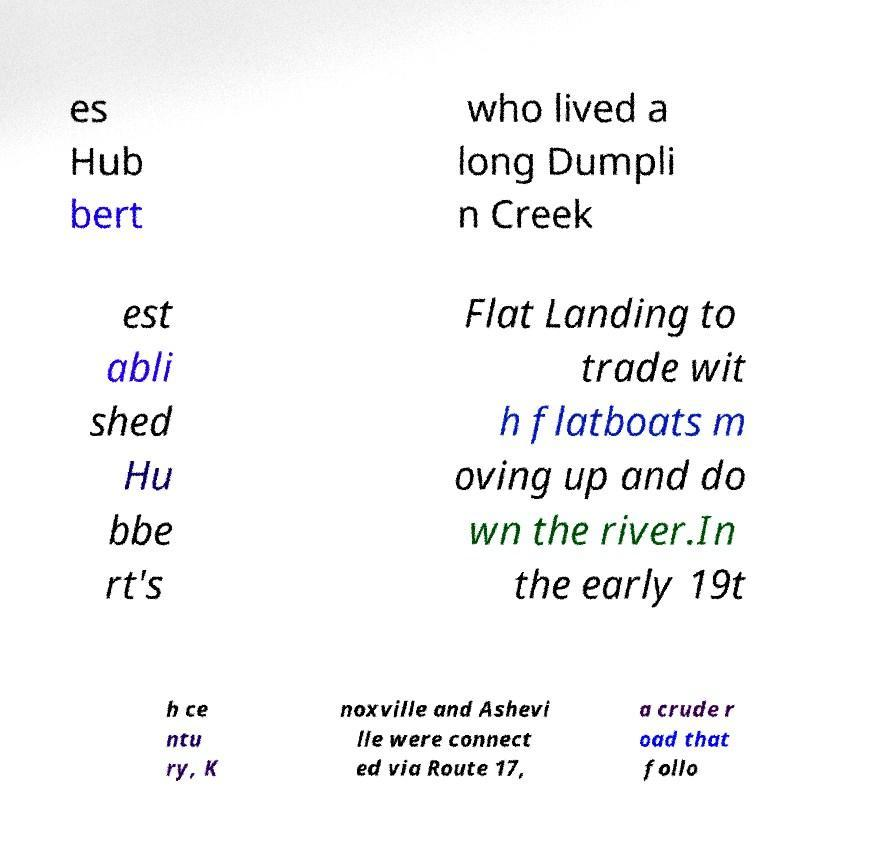Can you read and provide the text displayed in the image?This photo seems to have some interesting text. Can you extract and type it out for me? es Hub bert who lived a long Dumpli n Creek est abli shed Hu bbe rt's Flat Landing to trade wit h flatboats m oving up and do wn the river.In the early 19t h ce ntu ry, K noxville and Ashevi lle were connect ed via Route 17, a crude r oad that follo 